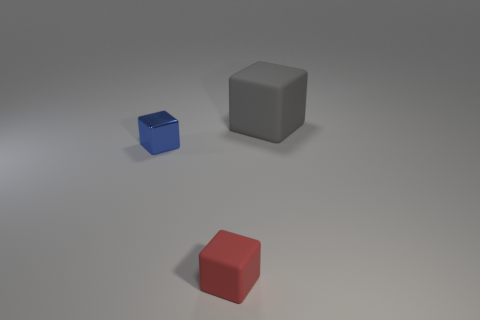Subtract all blue blocks. How many blocks are left? 2 Subtract all blue blocks. Subtract all purple cylinders. How many blocks are left? 2 Subtract all blue spheres. How many green cubes are left? 0 Subtract all tiny red things. Subtract all small blocks. How many objects are left? 0 Add 1 small matte cubes. How many small matte cubes are left? 2 Add 2 large purple metal things. How many large purple metal things exist? 2 Add 1 red metal spheres. How many objects exist? 4 Subtract all red cubes. How many cubes are left? 2 Subtract 0 brown blocks. How many objects are left? 3 